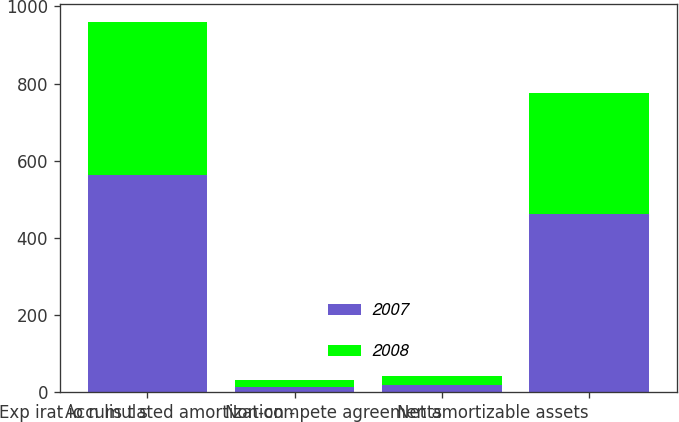Convert chart. <chart><loc_0><loc_0><loc_500><loc_500><stacked_bar_chart><ecel><fcel>Exp irat io n lis t s<fcel>Accumulated amortization -<fcel>Non-compete agreements<fcel>Net amortizable assets<nl><fcel>2007<fcel>563.7<fcel>14<fcel>19<fcel>461.2<nl><fcel>2008<fcel>395<fcel>16.4<fcel>22.9<fcel>315.6<nl></chart> 